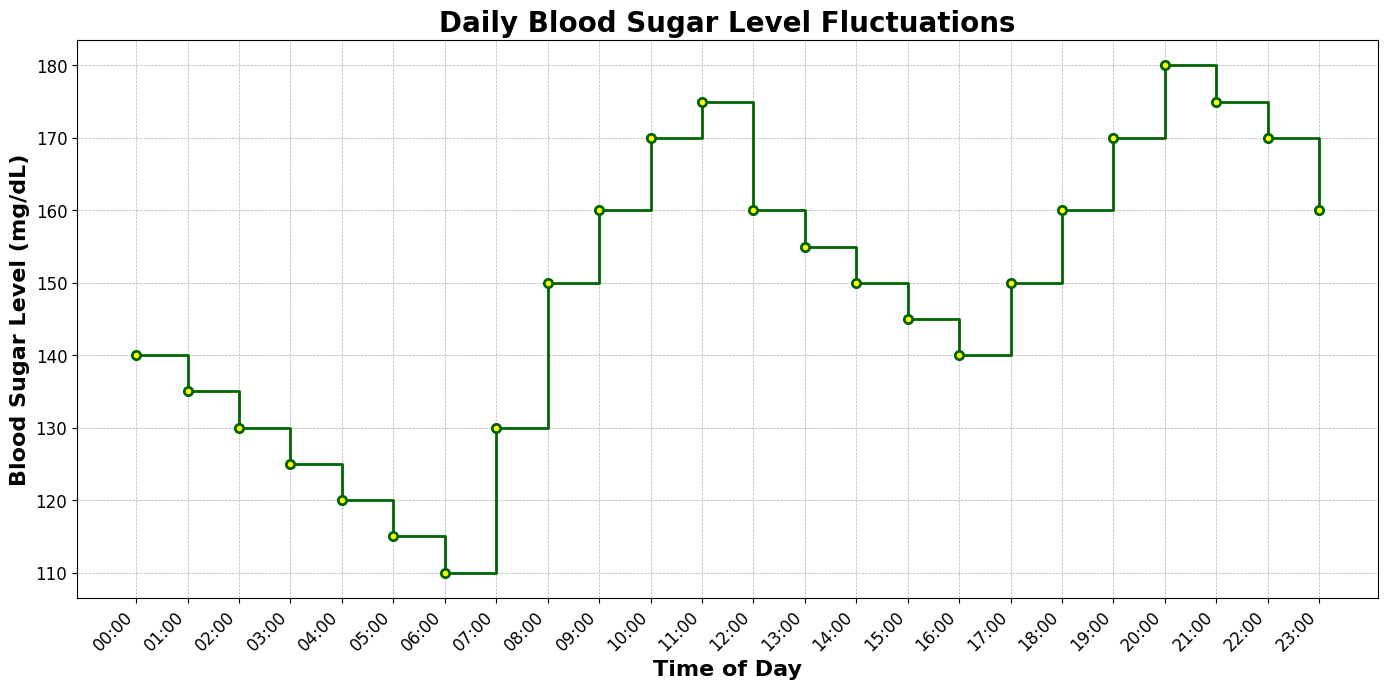What time of day does the blood sugar level peak? The plot indicates that the blood sugar level is at its highest point at 20:00, where it reaches 180 mg/dL. Just observe the y-axis values corresponding to the time labels on the x-axis to find the peak.
Answer: 20:00 At what time is the blood sugar level lowest? Look for the time point on the x-axis where the y-axis value (blood sugar level) is at its minimum. The graph shows the lowest level at 06:00 with a value of 110 mg/dL.
Answer: 06:00 How much does the blood sugar level increase from 07:00 to 08:00? Identify the blood sugar levels at 07:00 and 08:00 on the graph. At 07:00, it is 130 mg/dL, and at 08:00, it is 150 mg/dL. The increase is 150 - 130 = 20 mg/dL.
Answer: 20 mg/dL What is the average blood sugar level between 16:00 and 20:00? Find the blood sugar levels at 16:00, 17:00, 18:00, 19:00, and 20:00, which are 140, 150, 160, 170, and 180 mg/dL, respectively. Calculate the average: (140 + 150 + 160 + 170 + 180) / 5 = 160 mg/dL.
Answer: 160 mg/dL Between which two consecutive times is the largest increase in blood sugar level observed? Compare the differences between the blood sugar levels at each consecutive time point. The largest increase occurs between 19:00 and 20:00, where it rises from 170 mg/dL to 180 mg/dL, an increase of 10 mg/dL.
Answer: 19:00 and 20:00 What is the difference in blood sugar levels between 22:00 and 23:00? Identify the blood sugar levels at 22:00 and 23:00, which are 170 mg/dL and 160 mg/dL, respectively. The difference is 170 - 160 = 10 mg/dL.
Answer: 10 mg/dL During which time period does the blood sugar level remain constant and for how long? The blood sugar level stays constant from 11:00 to 12:00 at 175 mg/dL. This interval spans from 11:00 to 12:00, which is 1 hour.
Answer: 11:00 to 12:00, 1 hour Is there any time when the blood sugar level decreases significantly? If so, at what times? A significant decrease occurs from 11:00 to 12:00 (175 to 160 mg/dL) and from 20:00 to 21:00 (180 to 175 mg/dL). Identify steep declines, observing changes in the plot slope.
Answer: 11:00 to 12:00, 20:00 to 21:00 